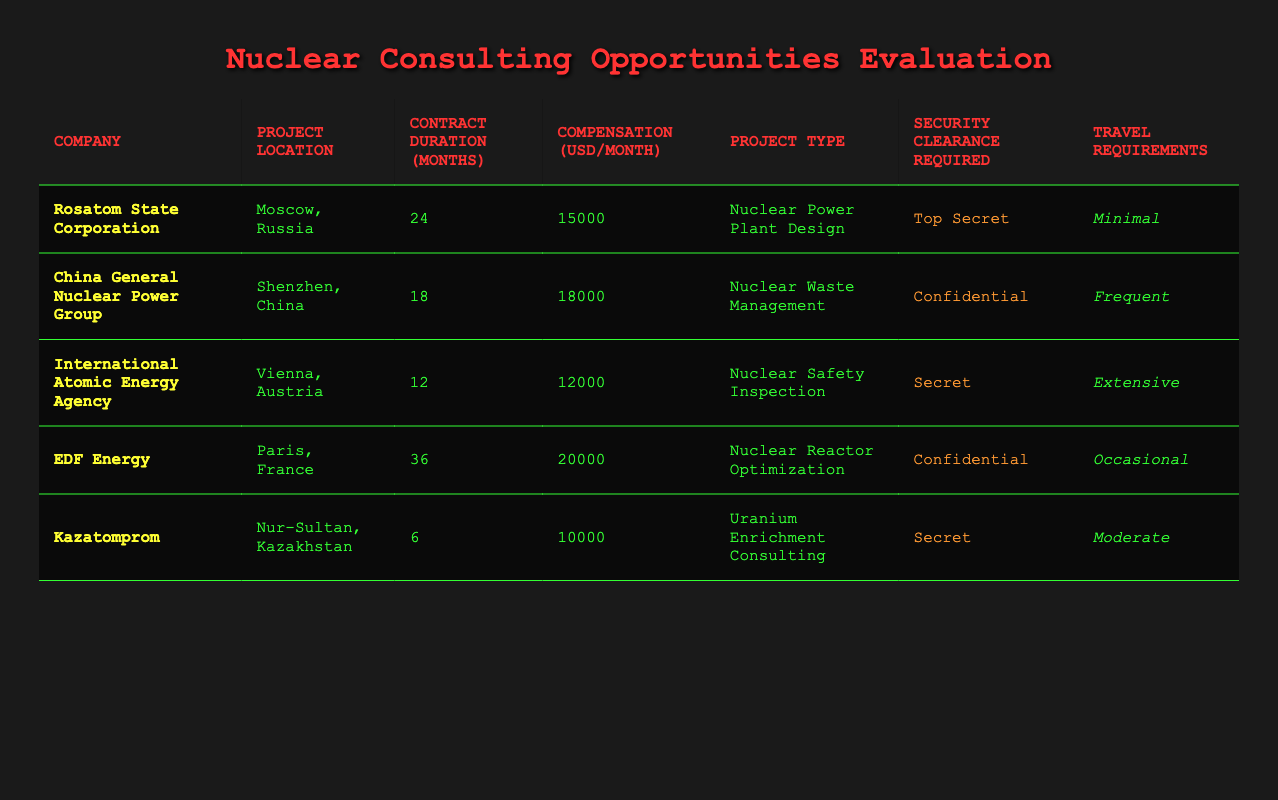What is the highest compensation offered among the projects? The compensation values from the table are 15000, 18000, 12000, 20000, and 10000. The highest value among these is 20000, which corresponds to EDF Energy.
Answer: 20000 Which project requires the longest contract duration? The contract durations listed are 24, 18, 12, 36, and 6 months. The longest duration is 36 months, associated with EDF Energy.
Answer: 36 Is security clearance required for all projects? Checking the security clearance requirements, "Top Secret," "Confidential," and "Secret" are present. This indicates that security clearance is indeed required for all projects listed in the table.
Answer: Yes What is the average duration of the projects? The durations are 24, 18, 12, 36, and 6 months. Summing these gives 96 months. Dividing by the number of projects (5) results in an average of 96/5 = 19.2 months.
Answer: 19.2 Are there any projects that have minimal travel requirements? The travel requirements listed are "Minimal," "Frequent," "Extensive," "Occasional," and "Moderate." Only Rosatom State Corporation has "Minimal" travel requirements.
Answer: Yes What is the compensation difference between the highest and lowest offered? The highest compensation is 20000 (EDF Energy) and the lowest is 10000 (Kazatomprom). The difference is 20000 - 10000 = 10000.
Answer: 10000 Which location has the shortest project duration? The contract durations are 24, 18, 12, 36, and 6 months. The shortest is 6 months, associated with Kazatomprom, located in Nur-Sultan, Kazakhstan.
Answer: Nur-Sultan, Kazakhstan How many projects require "Secret" level security clearance? The projects requiring "Secret" clearance are International Atomic Energy Agency and Kazatomprom. This counts to 2 projects.
Answer: 2 What project type offers the most compensation? The highest compensation project is for "Nuclear Reactor Optimization" with EDF Energy at 20000. This is the only project in that category with the highest pay.
Answer: Nuclear Reactor Optimization 